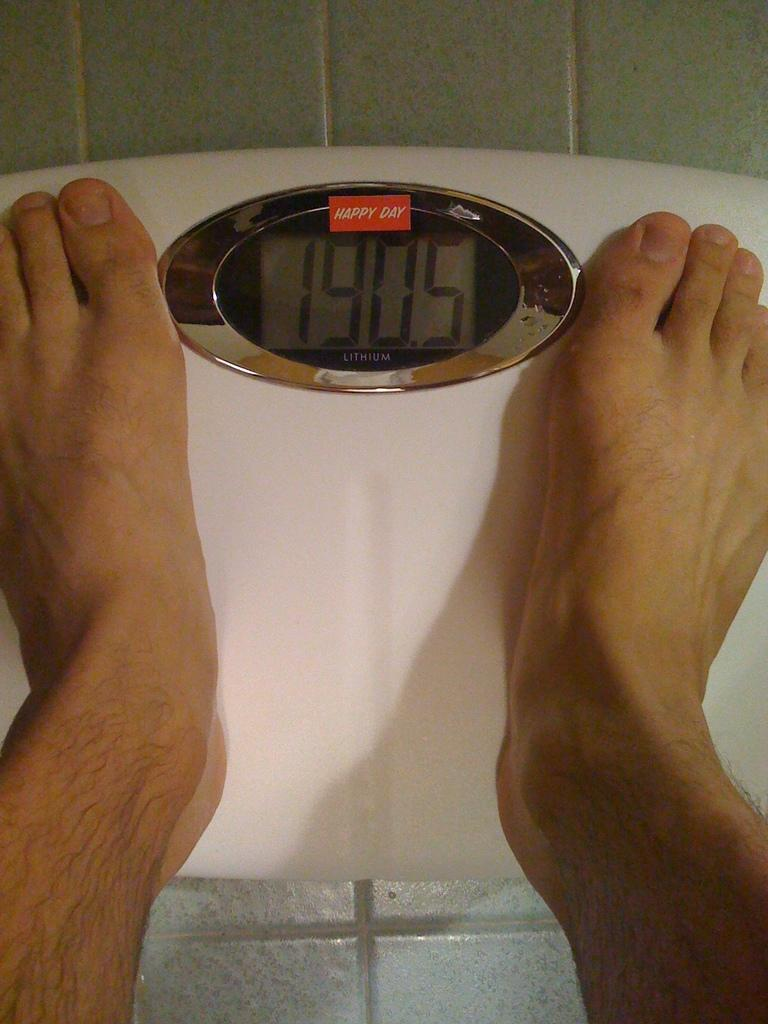Provide a one-sentence caption for the provided image. A man's feet on a white scale displaying 190.5 beneath a read Happy Day logo. 